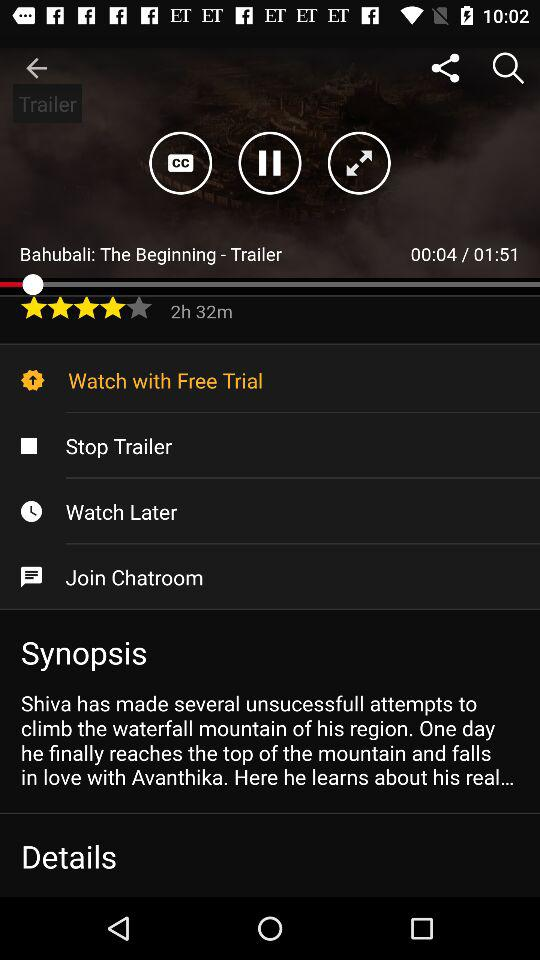What is the star rating of the movie? The rating is 4 stars. 